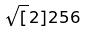Convert formula to latex. <formula><loc_0><loc_0><loc_500><loc_500>\sqrt { [ } 2 ] { 2 5 6 }</formula> 